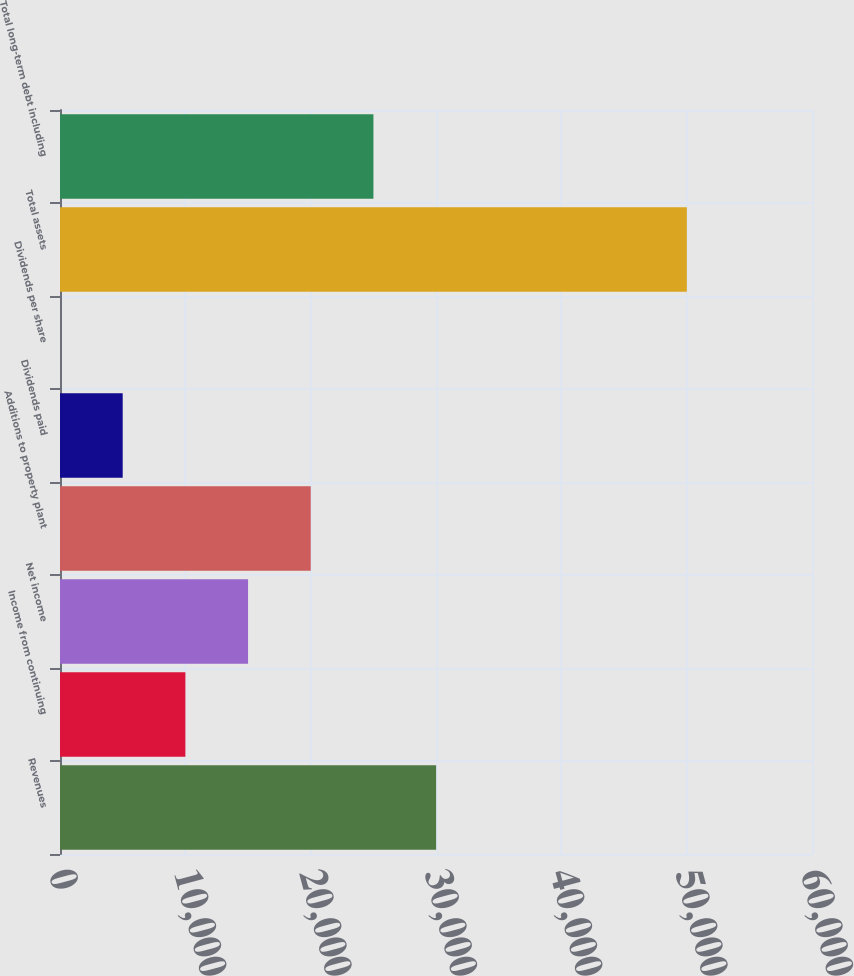Convert chart to OTSL. <chart><loc_0><loc_0><loc_500><loc_500><bar_chart><fcel>Revenues<fcel>Income from continuing<fcel>Net income<fcel>Additions to property plant<fcel>Dividends paid<fcel>Dividends per share<fcel>Total assets<fcel>Total long-term debt including<nl><fcel>30008.8<fcel>10003.6<fcel>15004.9<fcel>20006.2<fcel>5002.29<fcel>0.99<fcel>50014<fcel>25007.5<nl></chart> 